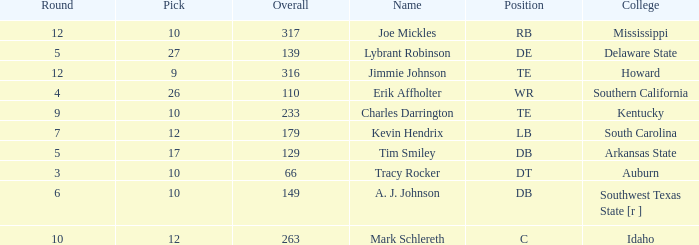What is the average Pick, when Name is "Lybrant Robinson", and when Overall is less than 139? None. 